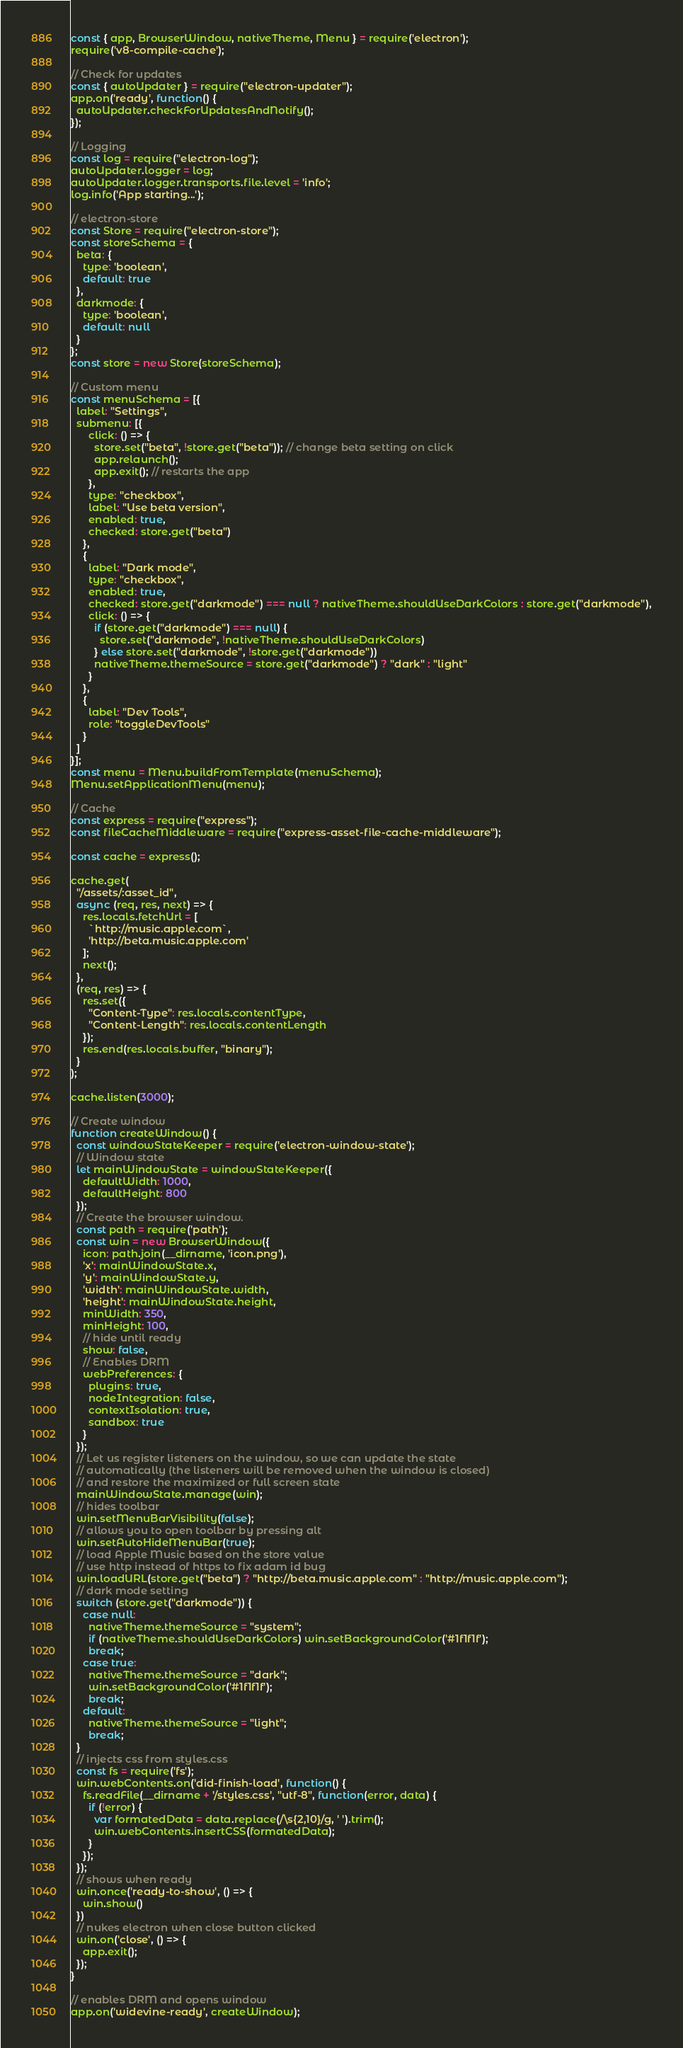<code> <loc_0><loc_0><loc_500><loc_500><_JavaScript_>const { app, BrowserWindow, nativeTheme, Menu } = require('electron');
require('v8-compile-cache');

// Check for updates
const { autoUpdater } = require("electron-updater");
app.on('ready', function() {
  autoUpdater.checkForUpdatesAndNotify();
});

// Logging
const log = require("electron-log");
autoUpdater.logger = log;
autoUpdater.logger.transports.file.level = 'info';
log.info('App starting...');

// electron-store
const Store = require("electron-store");
const storeSchema = {
  beta: {
    type: 'boolean',
    default: true
  },
  darkmode: {
    type: 'boolean',
    default: null
  }
};
const store = new Store(storeSchema);

// Custom menu
const menuSchema = [{
  label: "Settings",
  submenu: [{
      click: () => {
        store.set("beta", !store.get("beta")); // change beta setting on click
        app.relaunch();
        app.exit(); // restarts the app
      },
      type: "checkbox",
      label: "Use beta version",
      enabled: true,
      checked: store.get("beta")
    },
    {
      label: "Dark mode",
      type: "checkbox",
      enabled: true,
      checked: store.get("darkmode") === null ? nativeTheme.shouldUseDarkColors : store.get("darkmode"),
      click: () => {
        if (store.get("darkmode") === null) {
          store.set("darkmode", !nativeTheme.shouldUseDarkColors)
        } else store.set("darkmode", !store.get("darkmode"))
        nativeTheme.themeSource = store.get("darkmode") ? "dark" : "light"
      }
    },
    {
      label: "Dev Tools",
      role: "toggleDevTools"
    }
  ]
}];
const menu = Menu.buildFromTemplate(menuSchema);
Menu.setApplicationMenu(menu);

// Cache
const express = require("express");
const fileCacheMiddleware = require("express-asset-file-cache-middleware");

const cache = express();

cache.get(
  "/assets/:asset_id",
  async (req, res, next) => {    
    res.locals.fetchUrl = [
      `http://music.apple.com`,
      'http://beta.music.apple.com'
    ];
    next();
  },
  (req, res) => {
    res.set({
      "Content-Type": res.locals.contentType,
      "Content-Length": res.locals.contentLength
    });
    res.end(res.locals.buffer, "binary");
  }
);

cache.listen(3000);

// Create window
function createWindow() {
  const windowStateKeeper = require('electron-window-state');
  // Window state
  let mainWindowState = windowStateKeeper({
    defaultWidth: 1000,
    defaultHeight: 800
  });
  // Create the browser window.
  const path = require('path');
  const win = new BrowserWindow({
    icon: path.join(__dirname, 'icon.png'),
    'x': mainWindowState.x,
    'y': mainWindowState.y,
    'width': mainWindowState.width,
    'height': mainWindowState.height,
    minWidth: 350,
    minHeight: 100,
    // hide until ready
    show: false,
    // Enables DRM
    webPreferences: {
      plugins: true,
      nodeIntegration: false,
      contextIsolation: true,
      sandbox: true
    }
  });
  // Let us register listeners on the window, so we can update the state
  // automatically (the listeners will be removed when the window is closed)
  // and restore the maximized or full screen state
  mainWindowState.manage(win);
  // hides toolbar
  win.setMenuBarVisibility(false);
  // allows you to open toolbar by pressing alt
  win.setAutoHideMenuBar(true);
  // load Apple Music based on the store value
  // use http instead of https to fix adam id bug
  win.loadURL(store.get("beta") ? "http://beta.music.apple.com" : "http://music.apple.com");
  // dark mode setting
  switch (store.get("darkmode")) {
    case null:
      nativeTheme.themeSource = "system";
      if (nativeTheme.shouldUseDarkColors) win.setBackgroundColor('#1f1f1f');
      break;
    case true:
      nativeTheme.themeSource = "dark";
      win.setBackgroundColor('#1f1f1f');
      break;
    default:
      nativeTheme.themeSource = "light";
      break;
  }
  // injects css from styles.css
  const fs = require('fs');
  win.webContents.on('did-finish-load', function() {
    fs.readFile(__dirname + '/styles.css', "utf-8", function(error, data) {
      if (!error) {
        var formatedData = data.replace(/\s{2,10}/g, ' ').trim();
        win.webContents.insertCSS(formatedData);
      }
    });
  });
  // shows when ready
  win.once('ready-to-show', () => {
    win.show()
  })
  // nukes electron when close button clicked
  win.on('close', () => {
    app.exit();
  });
}

// enables DRM and opens window
app.on('widevine-ready', createWindow);
</code> 